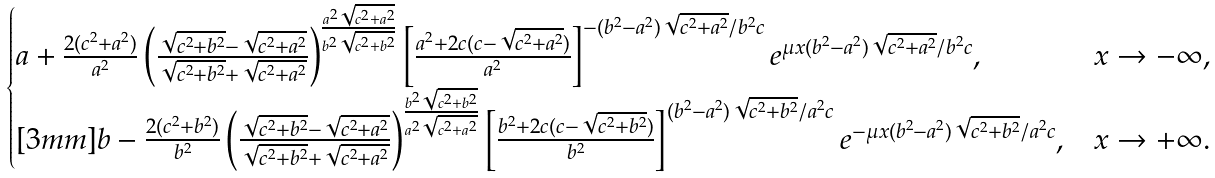<formula> <loc_0><loc_0><loc_500><loc_500>\begin{cases} a + \frac { 2 ( c ^ { 2 } + a ^ { 2 } ) } { a ^ { 2 } } \left ( \frac { \sqrt { c ^ { 2 } + b ^ { 2 } } - \sqrt { c ^ { 2 } + a ^ { 2 } } } { \sqrt { c ^ { 2 } + b ^ { 2 } } + \sqrt { c ^ { 2 } + a ^ { 2 } } } \right ) ^ { \frac { a ^ { 2 } \sqrt { c ^ { 2 } + a ^ { 2 } } } { b ^ { 2 } \sqrt { c ^ { 2 } + b ^ { 2 } } } } \left [ \frac { a ^ { 2 } + 2 c ( c - \sqrt { c ^ { 2 } + a ^ { 2 } } ) } { a ^ { 2 } } \right ] ^ { - ( b ^ { 2 } - a ^ { 2 } ) \sqrt { c ^ { 2 } + a ^ { 2 } } / b ^ { 2 } c } e ^ { \mu x ( b ^ { 2 } - a ^ { 2 } ) \sqrt { c ^ { 2 } + a ^ { 2 } } / b ^ { 2 } c } , & x \to - \infty , \\ [ 3 m m ] b - \frac { 2 ( c ^ { 2 } + b ^ { 2 } ) } { b ^ { 2 } } \left ( \frac { \sqrt { c ^ { 2 } + b ^ { 2 } } - \sqrt { c ^ { 2 } + a ^ { 2 } } } { \sqrt { c ^ { 2 } + b ^ { 2 } } + \sqrt { c ^ { 2 } + a ^ { 2 } } } \right ) ^ { \frac { b ^ { 2 } \sqrt { c ^ { 2 } + b ^ { 2 } } } { a ^ { 2 } \sqrt { c ^ { 2 } + a ^ { 2 } } } } \left [ \frac { b ^ { 2 } + 2 c ( c - \sqrt { c ^ { 2 } + b ^ { 2 } } ) } { b ^ { 2 } } \right ] ^ { ( b ^ { 2 } - a ^ { 2 } ) \sqrt { c ^ { 2 } + b ^ { 2 } } / a ^ { 2 } c } e ^ { - \mu x ( b ^ { 2 } - a ^ { 2 } ) \sqrt { c ^ { 2 } + b ^ { 2 } } / a ^ { 2 } c } , & x \to + \infty . \end{cases}</formula> 